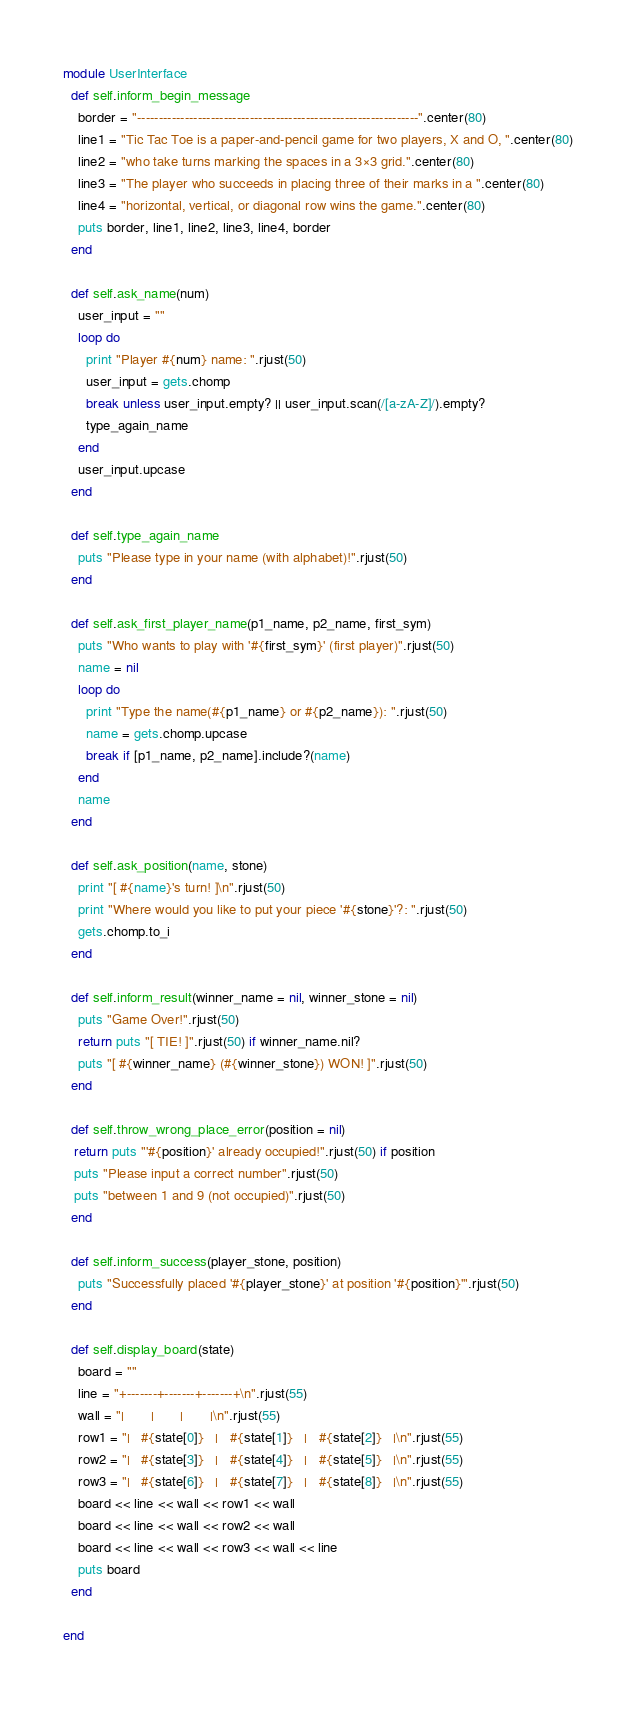<code> <loc_0><loc_0><loc_500><loc_500><_Ruby_>
module UserInterface
  def self.inform_begin_message
    border = "-----------------------------------------------------------------".center(80)
    line1 = "Tic Tac Toe is a paper-and-pencil game for two players, X and O, ".center(80)
    line2 = "who take turns marking the spaces in a 3×3 grid.".center(80)
    line3 = "The player who succeeds in placing three of their marks in a ".center(80)
    line4 = "horizontal, vertical, or diagonal row wins the game.".center(80)
    puts border, line1, line2, line3, line4, border
  end

  def self.ask_name(num)
    user_input = ""
    loop do
      print "Player #{num} name: ".rjust(50)
      user_input = gets.chomp
      break unless user_input.empty? || user_input.scan(/[a-zA-Z]/).empty?
      type_again_name
    end
    user_input.upcase
  end

  def self.type_again_name
    puts "Please type in your name (with alphabet)!".rjust(50)
  end

  def self.ask_first_player_name(p1_name, p2_name, first_sym)
    puts "Who wants to play with '#{first_sym}' (first player)".rjust(50)
    name = nil
    loop do
      print "Type the name(#{p1_name} or #{p2_name}): ".rjust(50)
      name = gets.chomp.upcase
      break if [p1_name, p2_name].include?(name)
    end
    name
  end

  def self.ask_position(name, stone)
    print "[ #{name}'s turn! ]\n".rjust(50)
    print "Where would you like to put your piece '#{stone}'?: ".rjust(50)
    gets.chomp.to_i
  end

  def self.inform_result(winner_name = nil, winner_stone = nil)
    puts "Game Over!".rjust(50)
    return puts "[ TIE! ]".rjust(50) if winner_name.nil?
    puts "[ #{winner_name} (#{winner_stone}) WON! ]".rjust(50)
  end

  def self.throw_wrong_place_error(position = nil)
   return puts "'#{position}' already occupied!".rjust(50) if position
   puts "Please input a correct number".rjust(50)
   puts "between 1 and 9 (not occupied)".rjust(50)
  end

  def self.inform_success(player_stone, position)
    puts "Successfully placed '#{player_stone}' at position '#{position}'".rjust(50)
  end

  def self.display_board(state)
    board = ""
    line = "+-------+-------+-------+\n".rjust(55)
    wall = "|       |       |       |\n".rjust(55)
    row1 = "|   #{state[0]}   |   #{state[1]}   |   #{state[2]}   |\n".rjust(55)
    row2 = "|   #{state[3]}   |   #{state[4]}   |   #{state[5]}   |\n".rjust(55)
    row3 = "|   #{state[6]}   |   #{state[7]}   |   #{state[8]}   |\n".rjust(55)
    board << line << wall << row1 << wall
    board << line << wall << row2 << wall
    board << line << wall << row3 << wall << line
    puts board
  end

end
</code> 